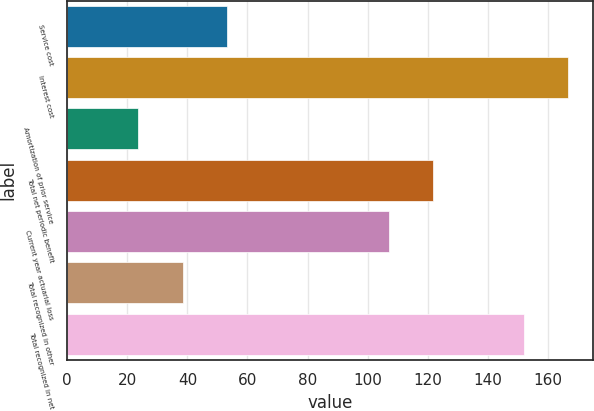<chart> <loc_0><loc_0><loc_500><loc_500><bar_chart><fcel>Service cost<fcel>Interest cost<fcel>Amortization of prior service<fcel>Total net periodic benefit<fcel>Current year actuarial loss<fcel>Total recognized in other<fcel>Total recognized in net<nl><fcel>53.1<fcel>166.7<fcel>23.7<fcel>121.7<fcel>107<fcel>38.4<fcel>152<nl></chart> 